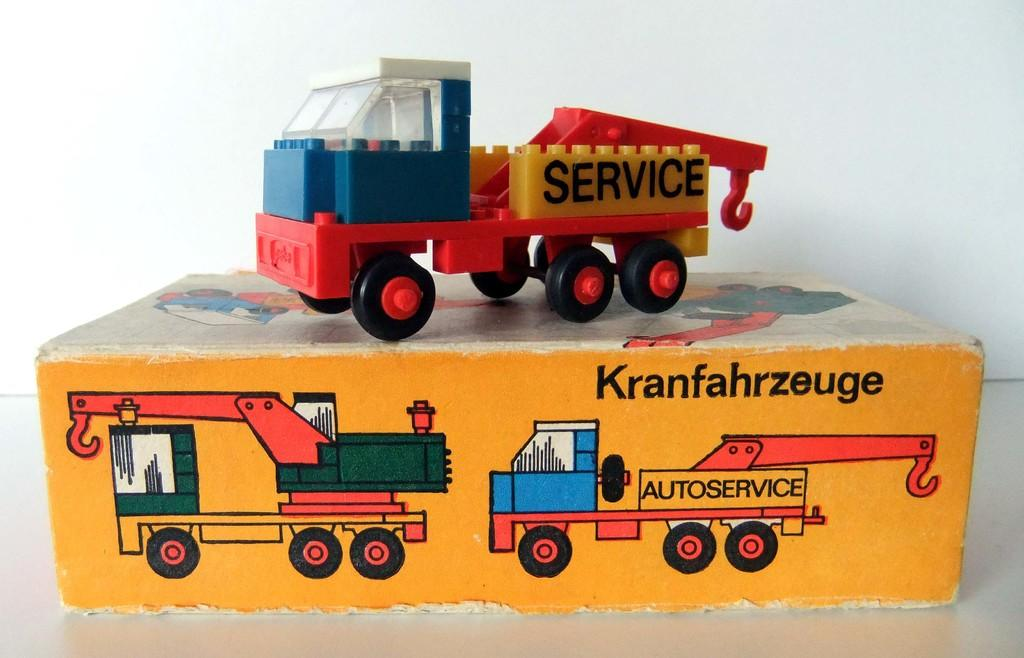What is located at the bottom of the image? There is a cardboard box at the bottom of the image. What can be seen on the cardboard box? The cardboard box has images and text on it. What is placed on top of the cardboard box? There is a toy vehicle on the cardboard box. How much salt is present in the image? There is no salt present in the image. What type of bomb is depicted on the cardboard box? There is no bomb present in the image; it features a toy vehicle on a cardboard box with images and text. 